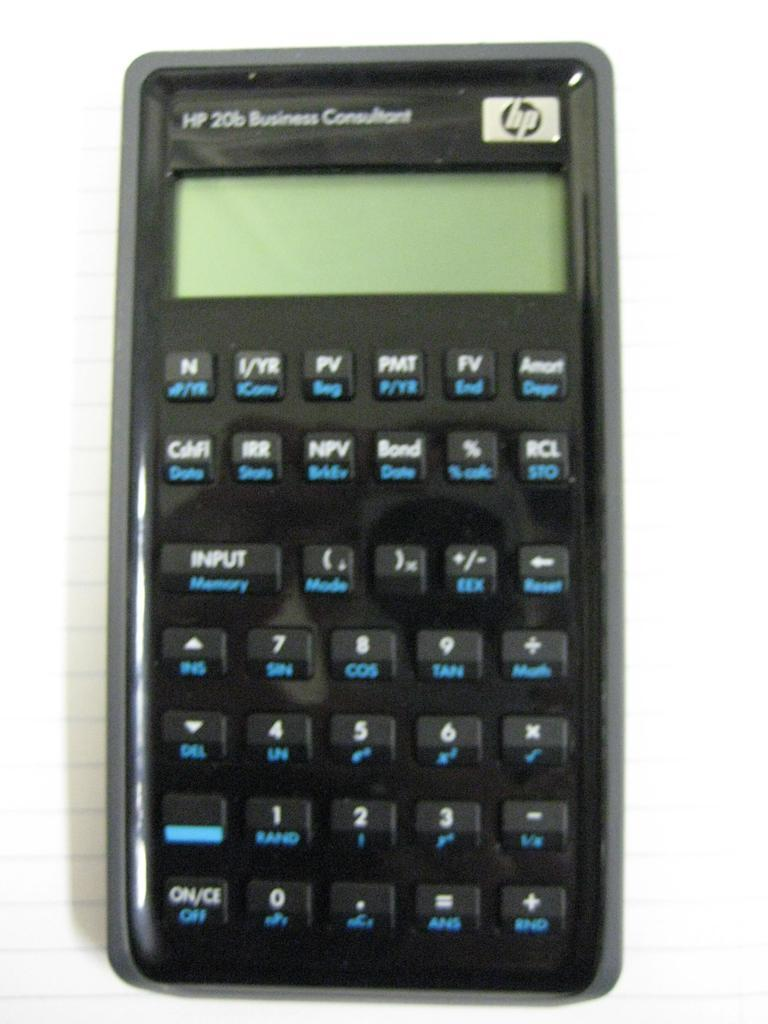<image>
Share a concise interpretation of the image provided. HP 20b Business Consultant Calculator with many features on it. 